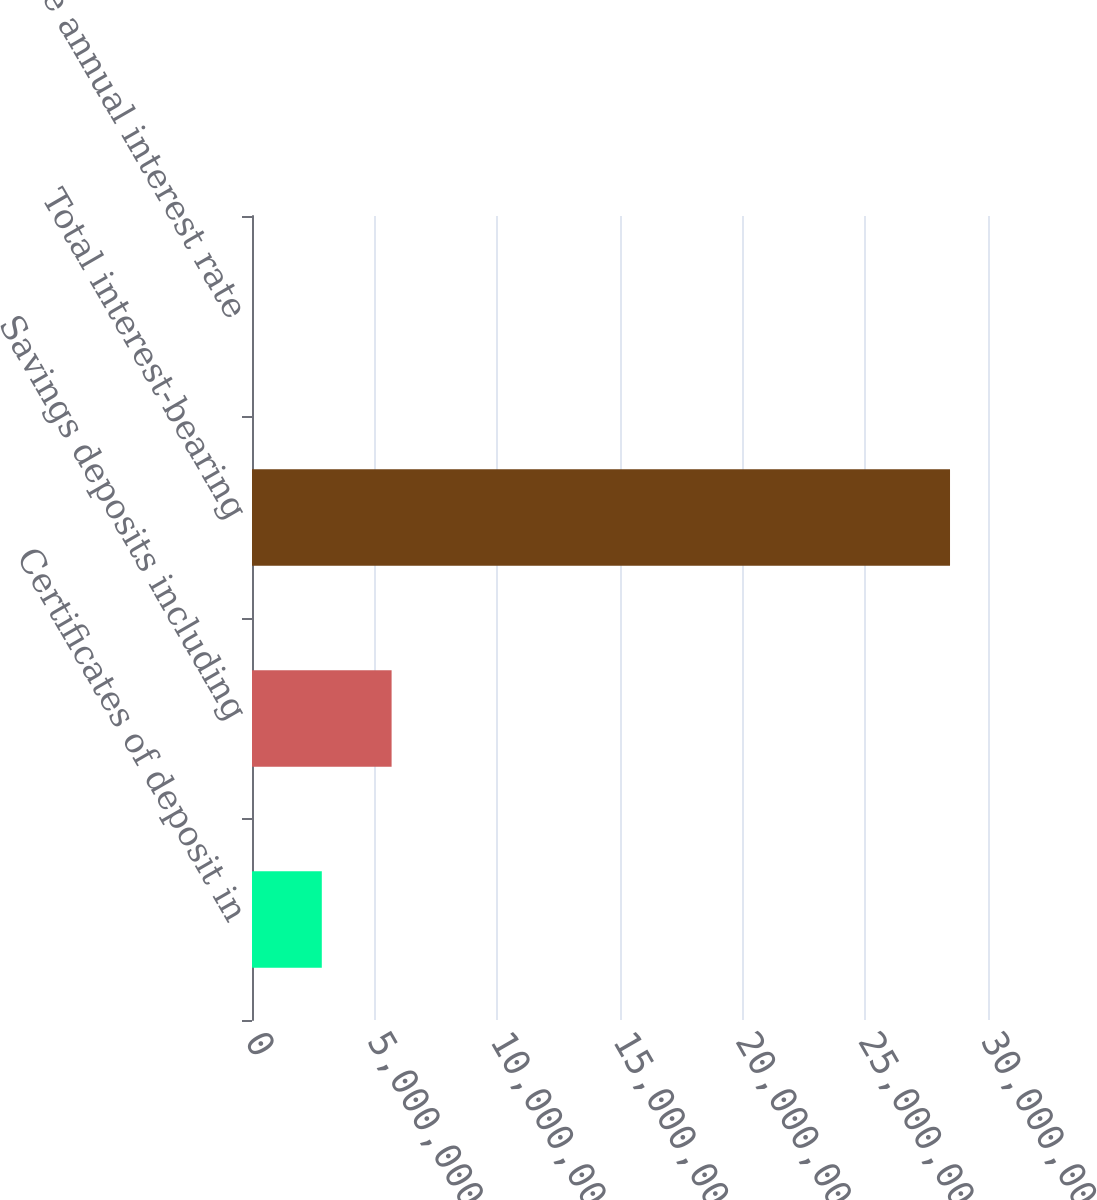Convert chart. <chart><loc_0><loc_0><loc_500><loc_500><bar_chart><fcel>Certificates of deposit in<fcel>Savings deposits including<fcel>Total interest-bearing<fcel>Average annual interest rate<nl><fcel>2.84522e+06<fcel>5.69043e+06<fcel>2.84521e+07<fcel>4.67<nl></chart> 